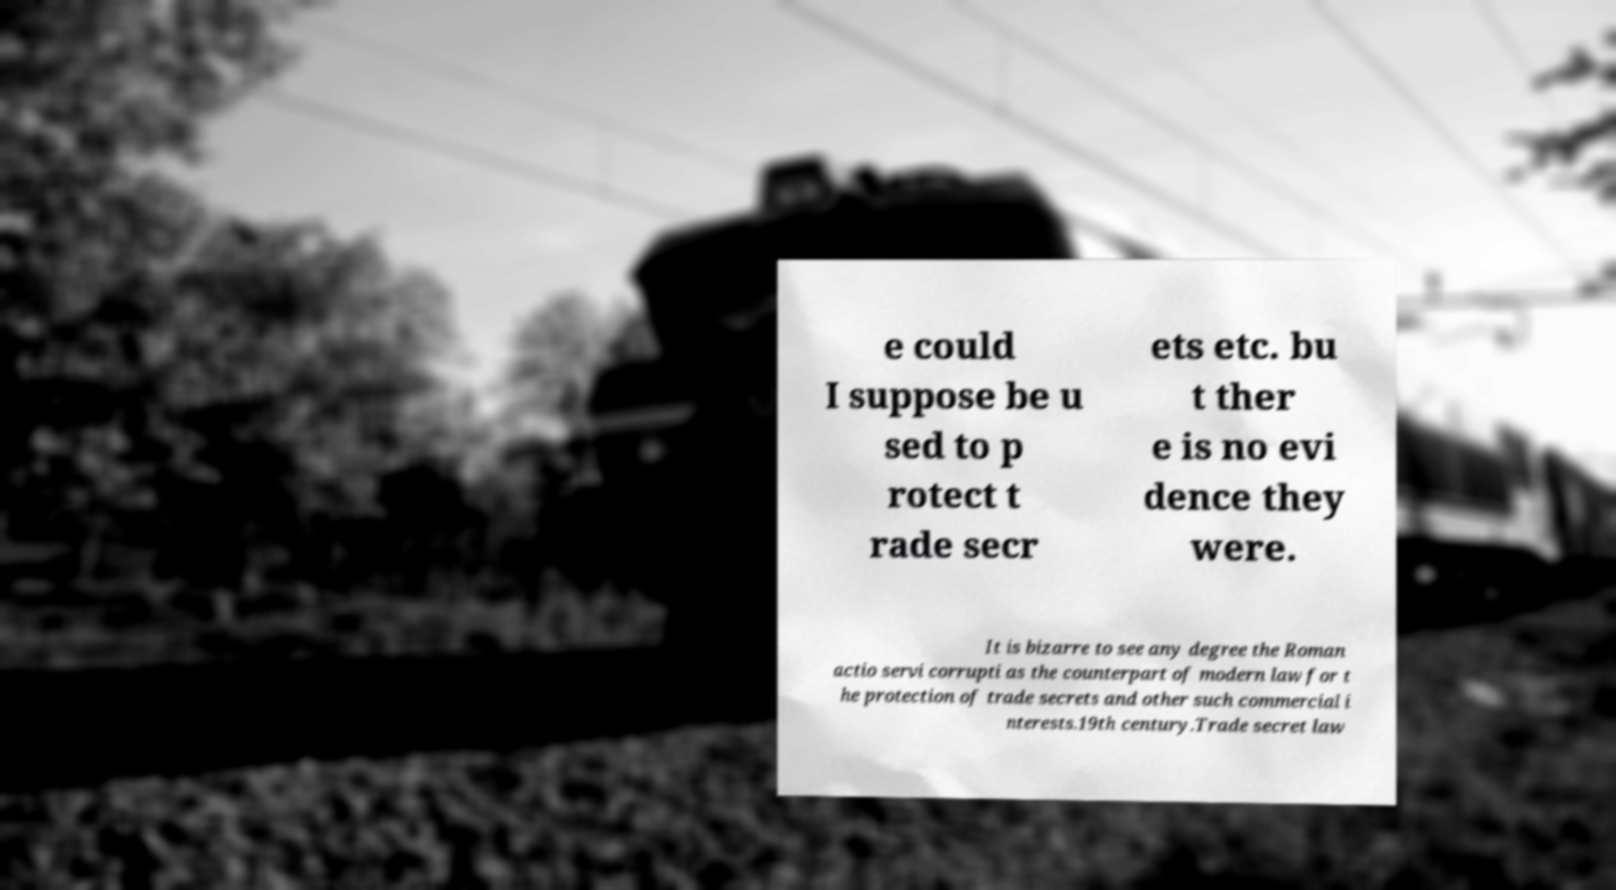For documentation purposes, I need the text within this image transcribed. Could you provide that? e could I suppose be u sed to p rotect t rade secr ets etc. bu t ther e is no evi dence they were. It is bizarre to see any degree the Roman actio servi corrupti as the counterpart of modern law for t he protection of trade secrets and other such commercial i nterests.19th century.Trade secret law 